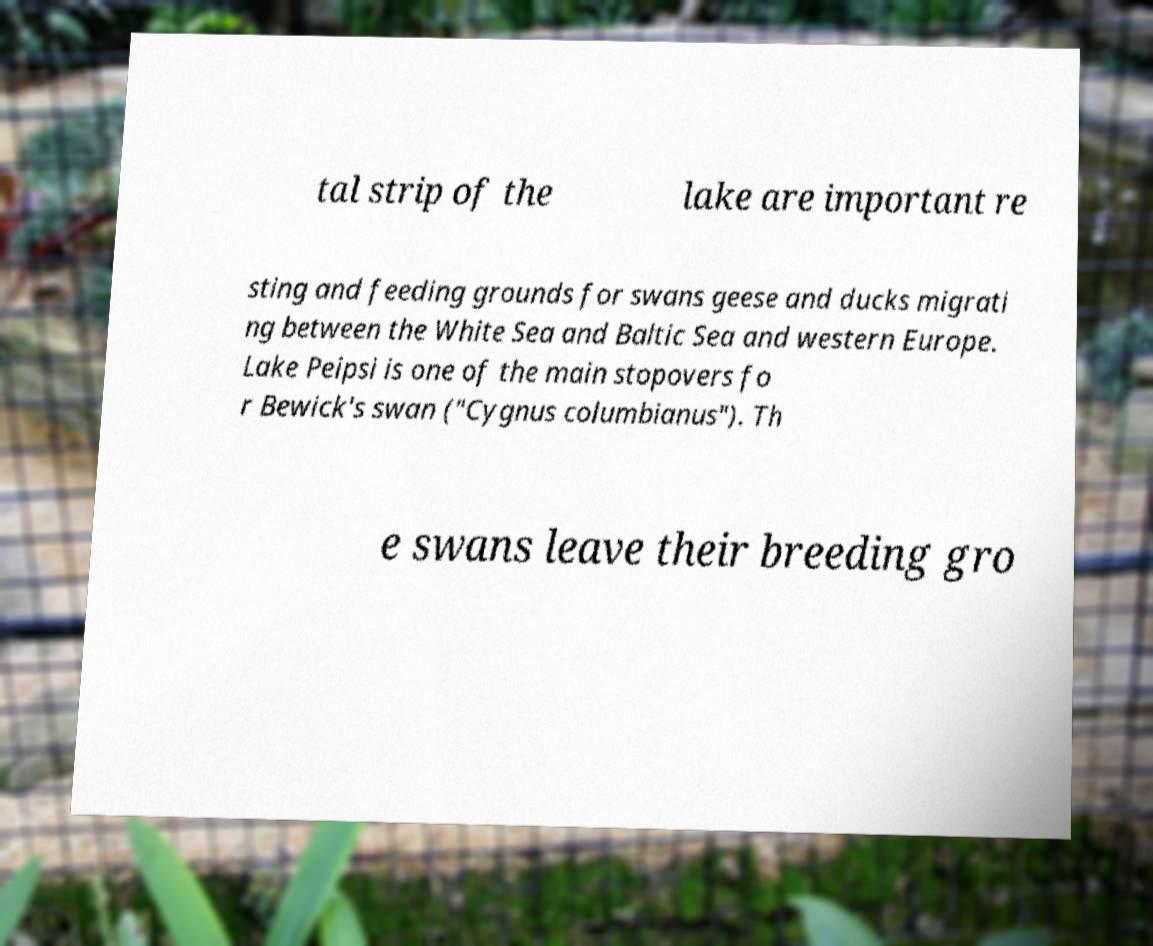There's text embedded in this image that I need extracted. Can you transcribe it verbatim? tal strip of the lake are important re sting and feeding grounds for swans geese and ducks migrati ng between the White Sea and Baltic Sea and western Europe. Lake Peipsi is one of the main stopovers fo r Bewick's swan ("Cygnus columbianus"). Th e swans leave their breeding gro 